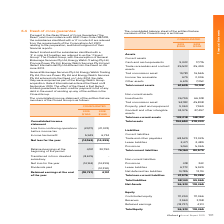According to Iselect's financial document, What is the effect of the Deed? iSelect Limited guarantees to each creditor payment in full of any debt in the event of winding up any of the entities in the Closed Group. The document states: "8 September 2014. The effect of the Deed is that iSelect Limited guarantees to each creditor payment in full of any debt in the event of winding up an..." Also, What is the income tax benefit in 2019? According to the financial document, 5,949 (in thousands). The relevant text states: "Income tax benefit 5,949 6,734..." Also, What is the loss from continuing operations before income tax in 2019? According to the financial document, 20,111 (in thousands). The relevant text states: "oss from continuing operations before income tax (20,111) (21,033)..." Also, can you calculate: What is the percentage change in the Loss from continuing operations before income tax from 2018 to 2019? To answer this question, I need to perform calculations using the financial data. The calculation is: (20,111-21,033)/21,033, which equals -4.38 (percentage). This is based on the information: "oss from continuing operations before income tax (20,111) (21,033) continuing operations before income tax (20,111) (21,033)..." The key data points involved are: 20,111, 21,033. Also, can you calculate: What is the percentage change in the income tax benefit from 2018 to 2019? To answer this question, I need to perform calculations using the financial data. The calculation is: (5,949-6,734)/6,734, which equals -11.66 (percentage). This is based on the information: "Income tax benefit 5,949 6,734 Income tax benefit 5,949 6,734..." The key data points involved are: 5,949, 6,734. Additionally, In which year is there a greater net loss for the year? According to the financial document, 2018. The relevant text states: "2019 $’000 2018 $’000..." 